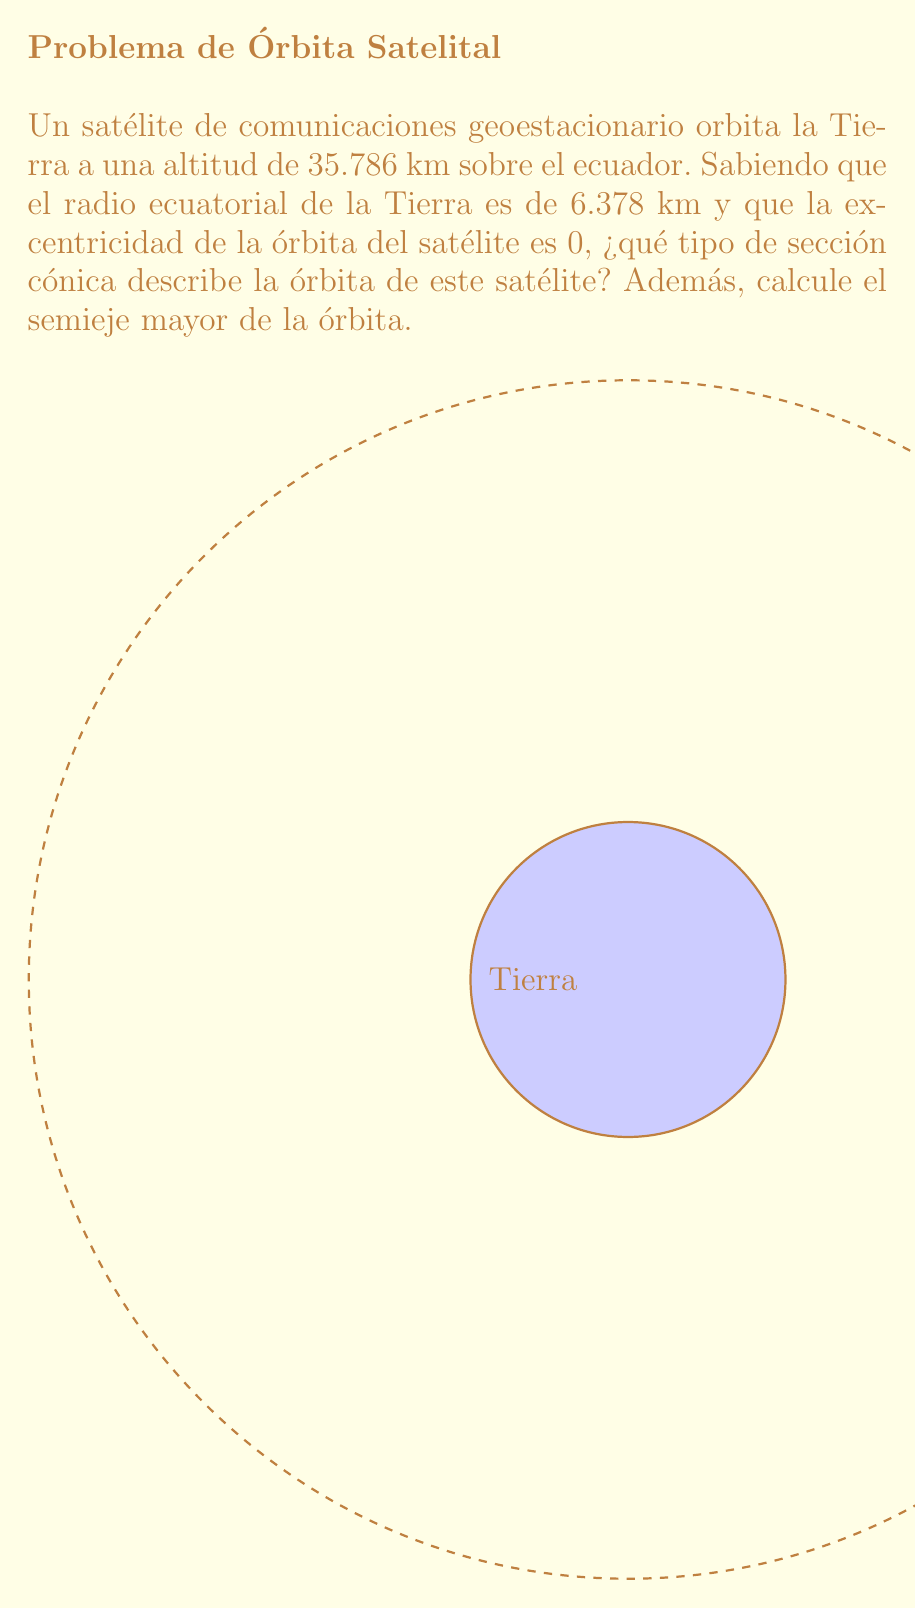Teach me how to tackle this problem. Para determinar la forma de la órbita del satélite, debemos analizar sus características:

1) La excentricidad (e) de la órbita es 0. Esto es clave para identificar el tipo de sección cónica.

2) Recordemos las relaciones entre excentricidad y tipos de órbitas:
   - Círculo: e = 0
   - Elipse: 0 < e < 1
   - Parábola: e = 1
   - Hipérbola: e > 1

3) Como la excentricidad es 0, la órbita es circular.

4) Para calcular el semieje mayor (a), que en este caso es igual al radio de la órbita:
   
   $$a = R_{Tierra} + h_{satélite}$$
   
   donde $R_{Tierra}$ es el radio de la Tierra y $h_{satélite}$ es la altitud del satélite.

5) Sustituyendo los valores:

   $$a = 6,378 \text{ km} + 35,786 \text{ km} = 42,164 \text{ km}$$

6) Este resultado confirma que el satélite está en una órbita geoestacionaria, ya que la altitud de 35,786 km es característica de estas órbitas que tienen un período de 24 horas, coincidiendo con la rotación de la Tierra.
Answer: Círculo con semieje mayor de 42,164 km 